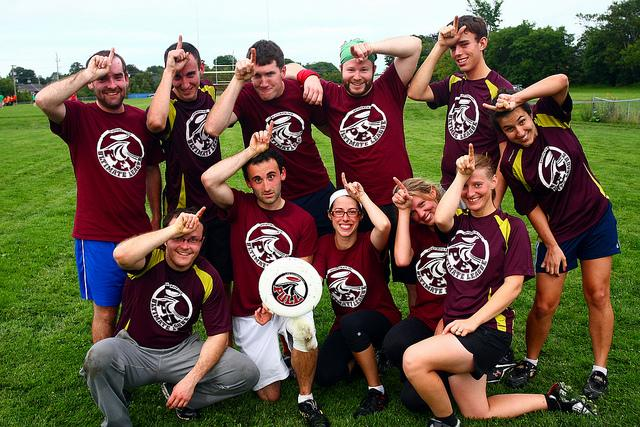What is the finger everyone is holding up commonly called?

Choices:
A) big finger
B) ring finger
C) index finger
D) thrust finger index finger 